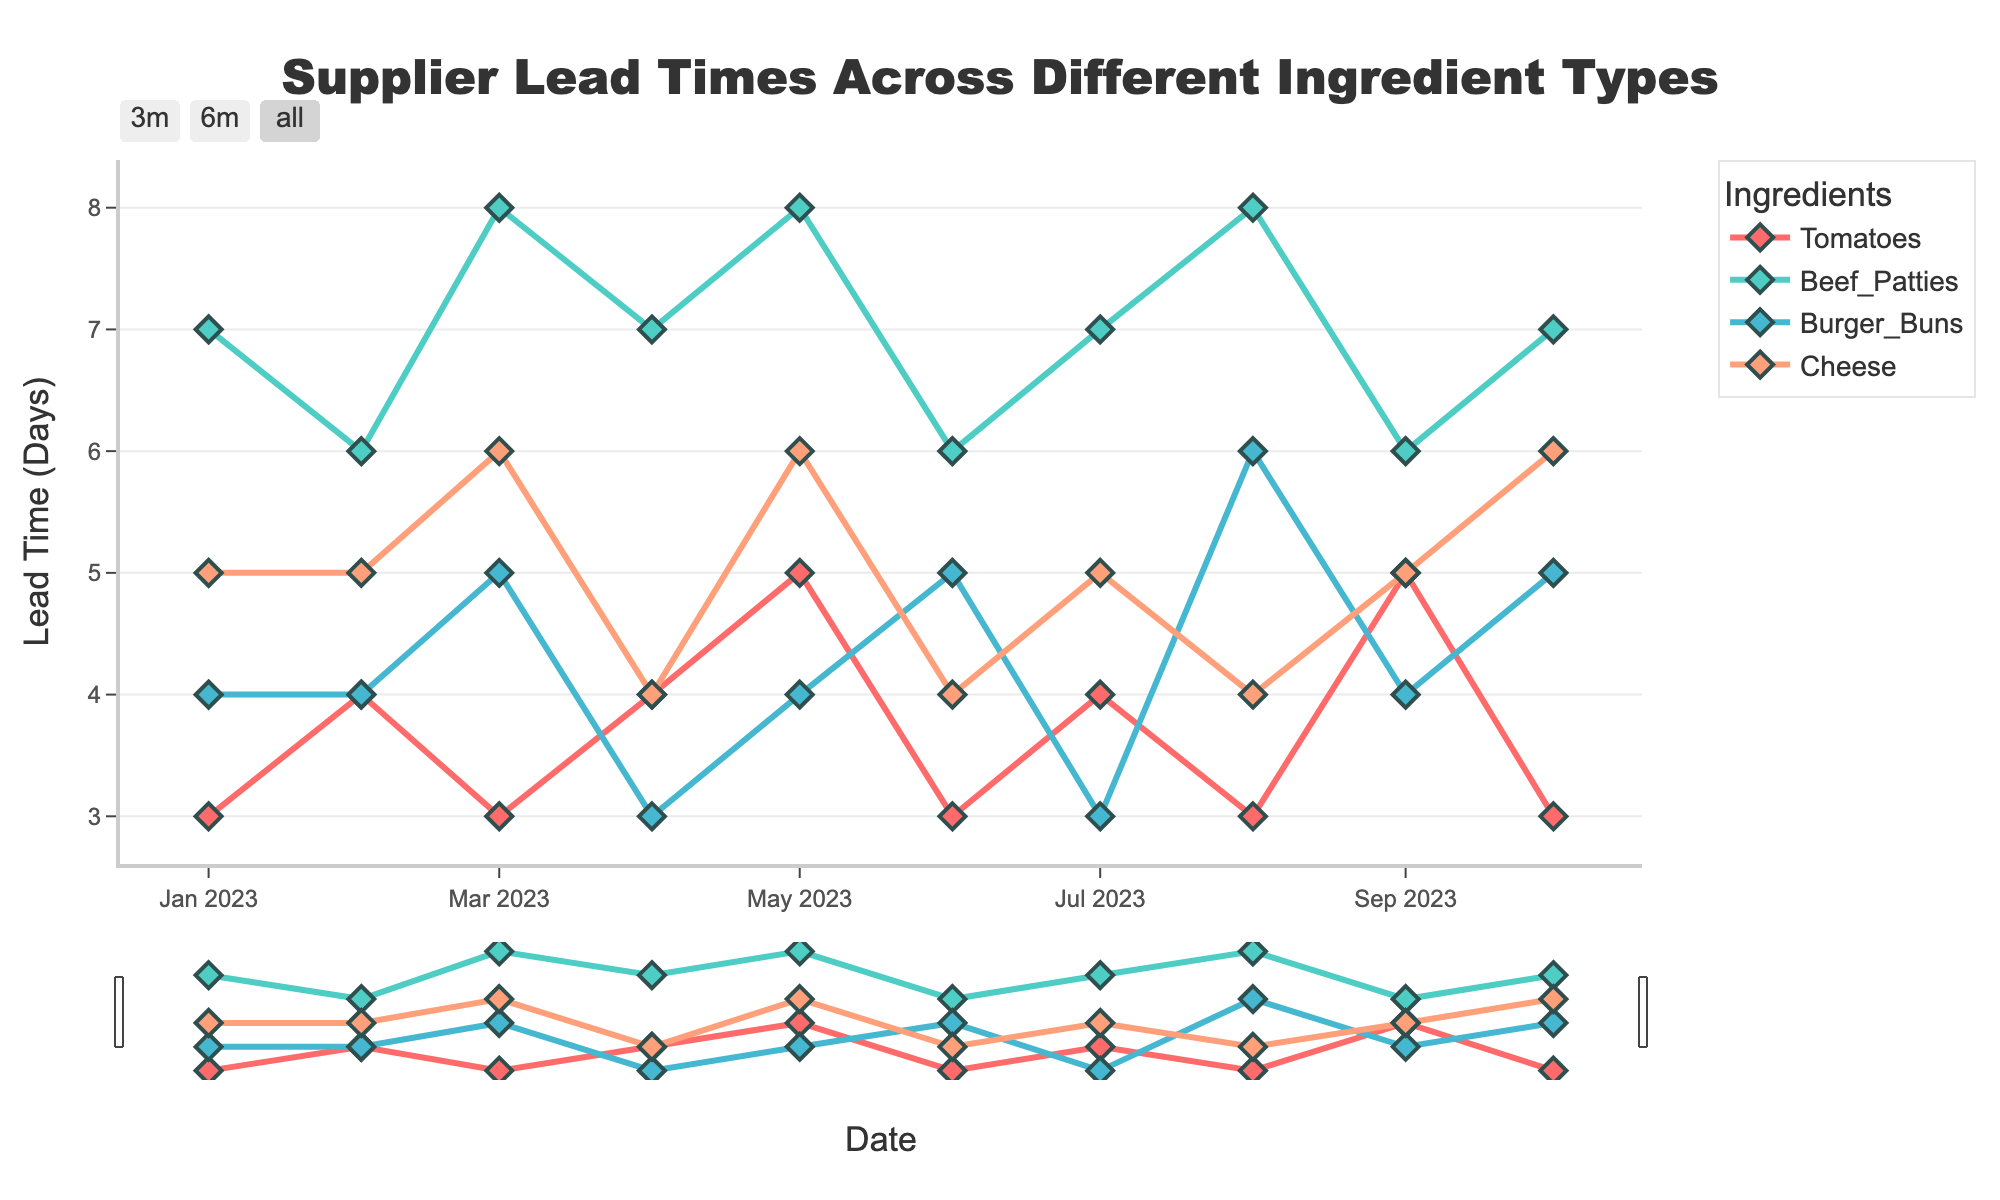What's the title of the figure? The title is prominently displayed at the top of the plot. It is standard in figures to summarize the main topic of the visualization.
Answer: Supplier Lead Times Across Different Ingredient Types What are the ingredients shown in the figure? The ingredients are indicated by different traces in the legend.
Answer: Tomatoes, Beef Patties, Burger Buns, Cheese On which date does the data start and end? The x-axis shows the date range for the time series. The starting and ending dates are the first and last ticks on this axis.
Answer: From 2023-01-01 to 2023-10-01 Which ingredient has shown the highest variability in lead times? By observing the fluctuations in the lead time series for each ingredient, Beef Patties exhibit the most variability with changes ranging from 6 to 8 days.
Answer: Beef Patties What is the average lead time for Cheese over the entire period? To find the average lead time for Cheese, sum the lead times for Cheese over all months and divide by the number of months. (5+5+6+4+6+4+5+4+5+6)/10 gives 50/10.
Answer: 5 days Which month has the longest lead time for Tomatoes? By examining the lead time peaks for Tomatoes on the plot, the highest lead time is noticed in May and September.
Answer: May and September Did any ingredient have constant lead times for consecutive months? By comparing consecutive data points for each ingredient, the lead times for Cheese (4 to 4 in April and June) and Burger Buns (4 to 4 in February) did not change.
Answer: Yes, Cheese (April, June) and Burger Buns (February) How do the lead times for Tomatoes and Beef Patties in March compare? By looking at both series for March where they intersect on the time axis, the lead times for Tomatoes are 3 days, and for Beef Patties, it's 8 days.
Answer: Tomatoes: 3 days, Beef Patties: 8 days What trend is noticeable for Burger Buns over the year? The plot shows fluctuation; starting from January, with some peaks and drops indicating variability. The general trend can be described as alternating up and down movements.
Answer: Fluctuating 